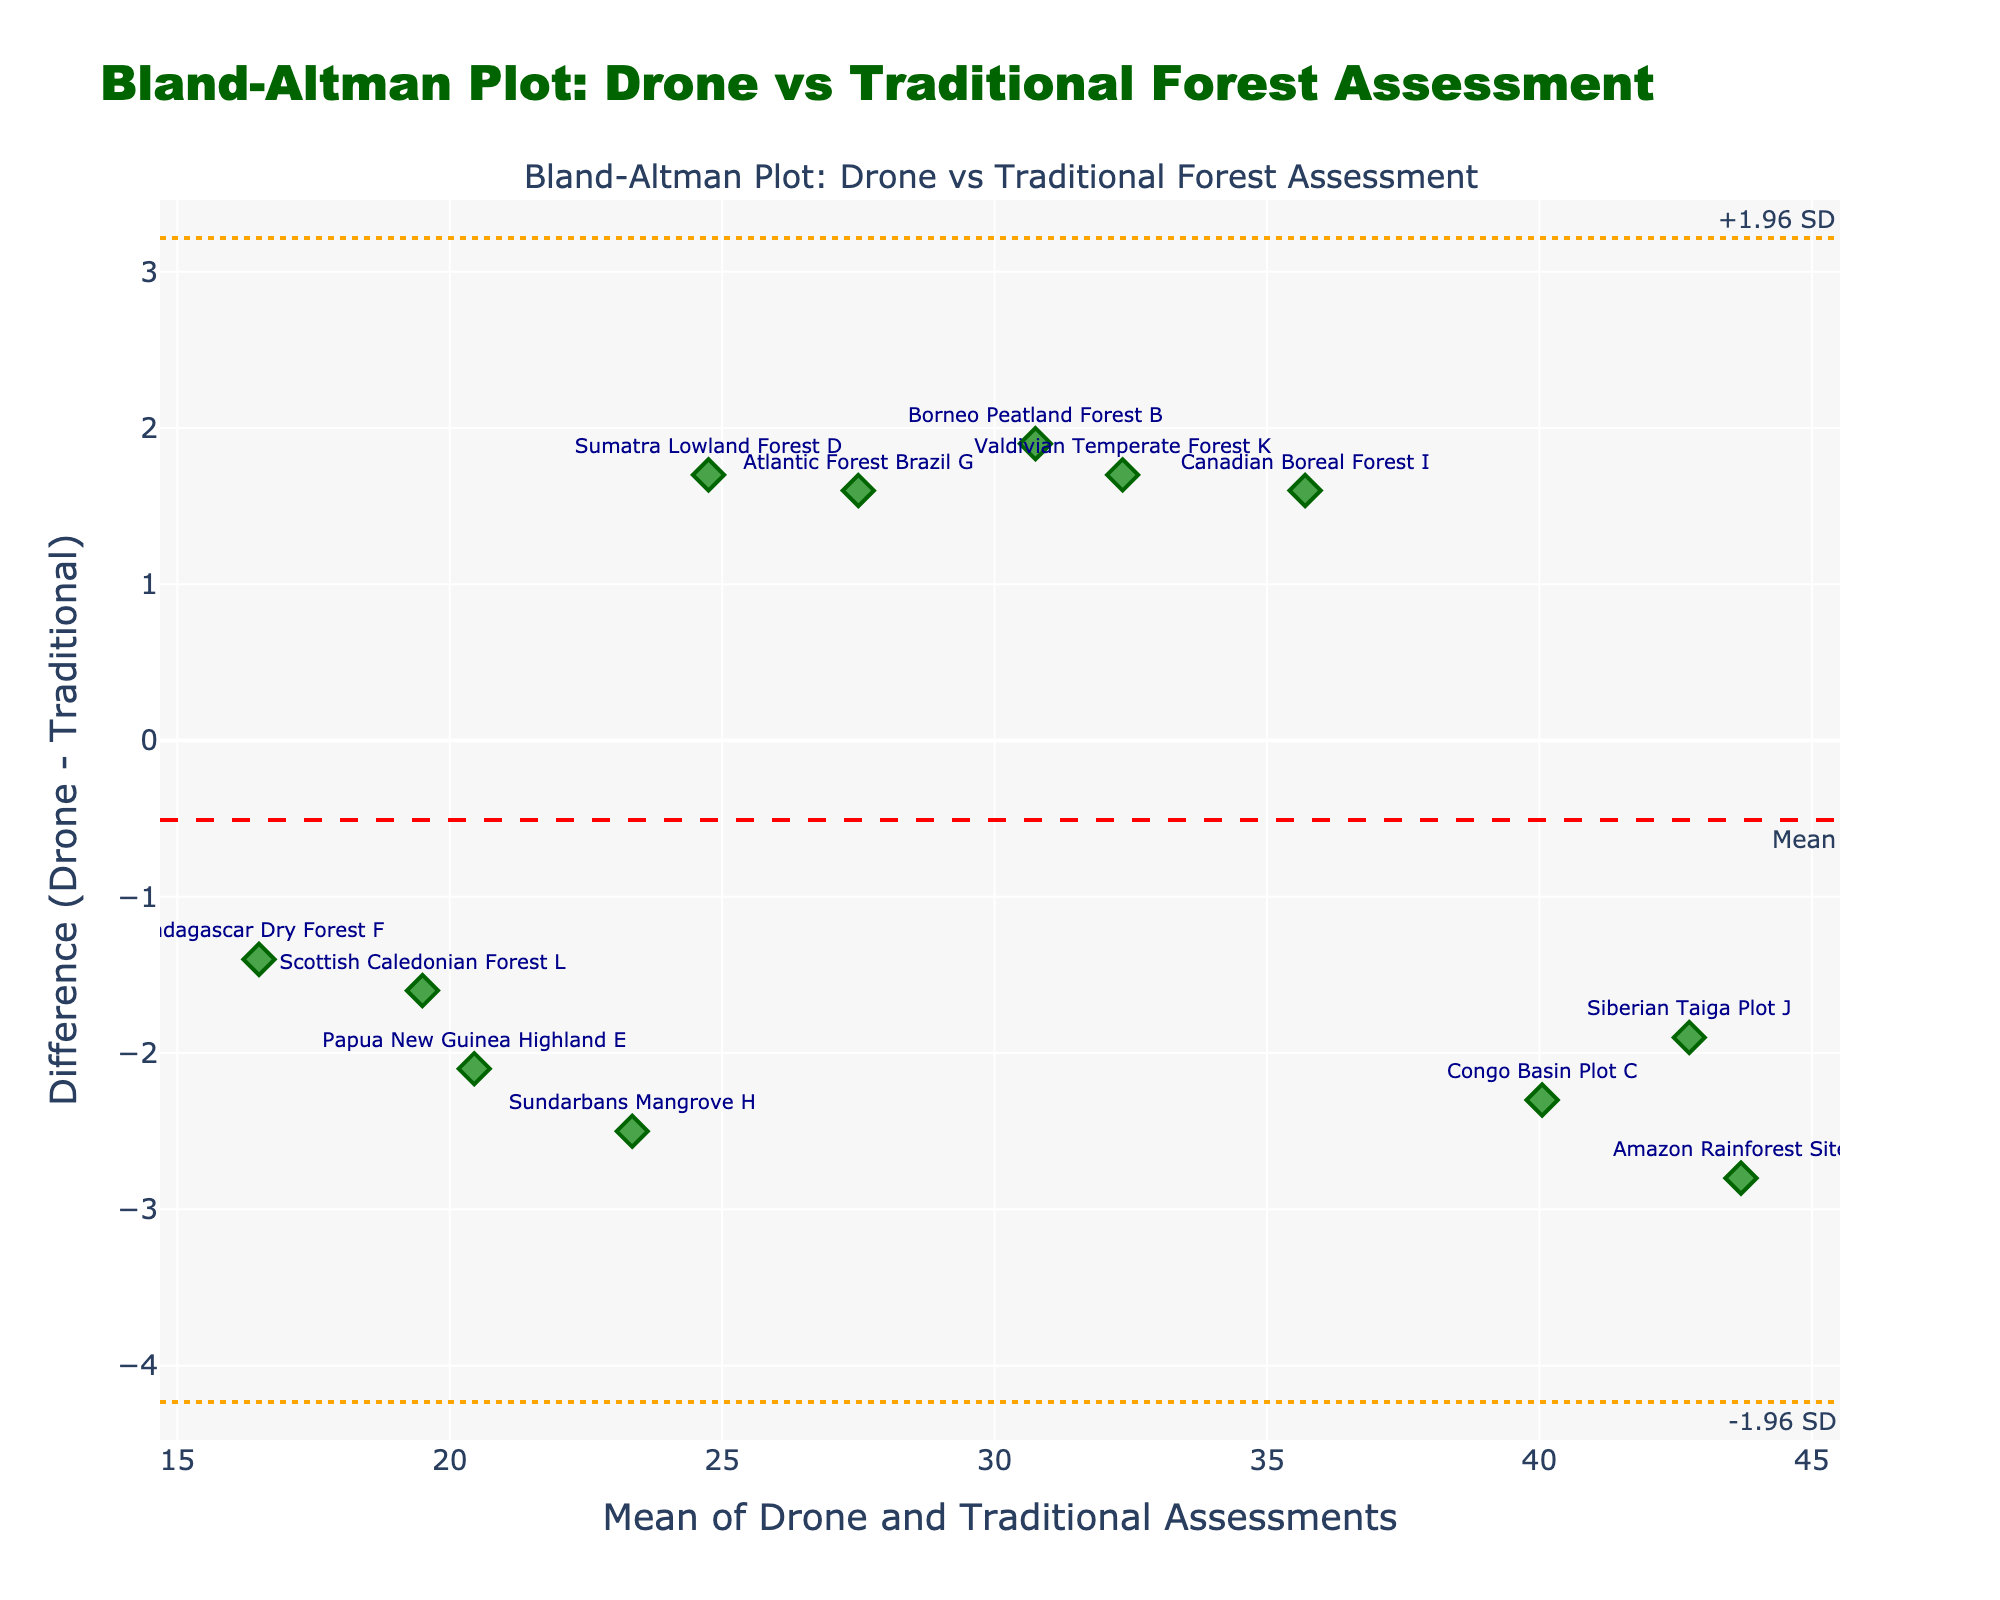How many data points are there in the plot? Count the number of markers or labels on the plot. There are 12 assessments, so there are 12 data points.
Answer: 12 What's the title of the plot? The title is displayed at the top center of the plot.
Answer: Bland-Altman Plot: Drone vs Traditional Forest Assessment What does the red dashed line represent? The red dashed line represents the mean difference between the drone and traditional assessments.
Answer: The mean difference What are the colors used for the limits of agreement lines in the plot? The lines representing limits of agreement are colored in orange.
Answer: Orange Which forest assessment has the largest positive difference between drone and traditional methods? Check the data point with the highest positive value on the y-axis (difference axis). The Amazon Rainforest Site A shows the largest positive difference.
Answer: Amazon Rainforest Site A Calculate the mean value of forest assessments for the Congo Basin Plot C using both methods. The mean value is calculated by averaging the DroneAssessment and TraditionalAssessment for the Congo Basin Plot C: (38.9 + 41.2) / 2 = 80.1 / 2.
Answer: 40.05 Compare the assessments of Amazon Rainforest Site A and Siberian Taiga Plot J: which one has a higher traditional assessment value? Check the y-values of both Amazon Rainforest Site A and Siberian Taiga Plot J for TraditionalAssessment. The Amazon Rainforest Site A has a TraditionalAssessment of 45.1, while the Siberian Taiga Plot J has a value of 43.7.
Answer: Amazon Rainforest Site A What is the difference in drone assessments between Sundarbans Mangrove H and Scottish Caledonian Forest L? The difference in DroneAssessment is calculated by subtracting the lower value from the higher one: 22.1 (Sundarbans Mangrove H) - 18.7 (Scottish Caledonian Forest L) = 3.4.
Answer: 3.4 Identify a point that lies close to the mean difference line. Identify a data point lying near the red dashed line. The Congo Basin Plot C is very close to the mean difference line.
Answer: Congo Basin Plot C What is the value of the lower limit of agreement? The lower limit of agreement line is labeled as "-1.96 SD" on the plot. Its value can be read from this annotation on the y-axis.
Answer: (Exact value depends on the plotted limits, which is not given in this description) 